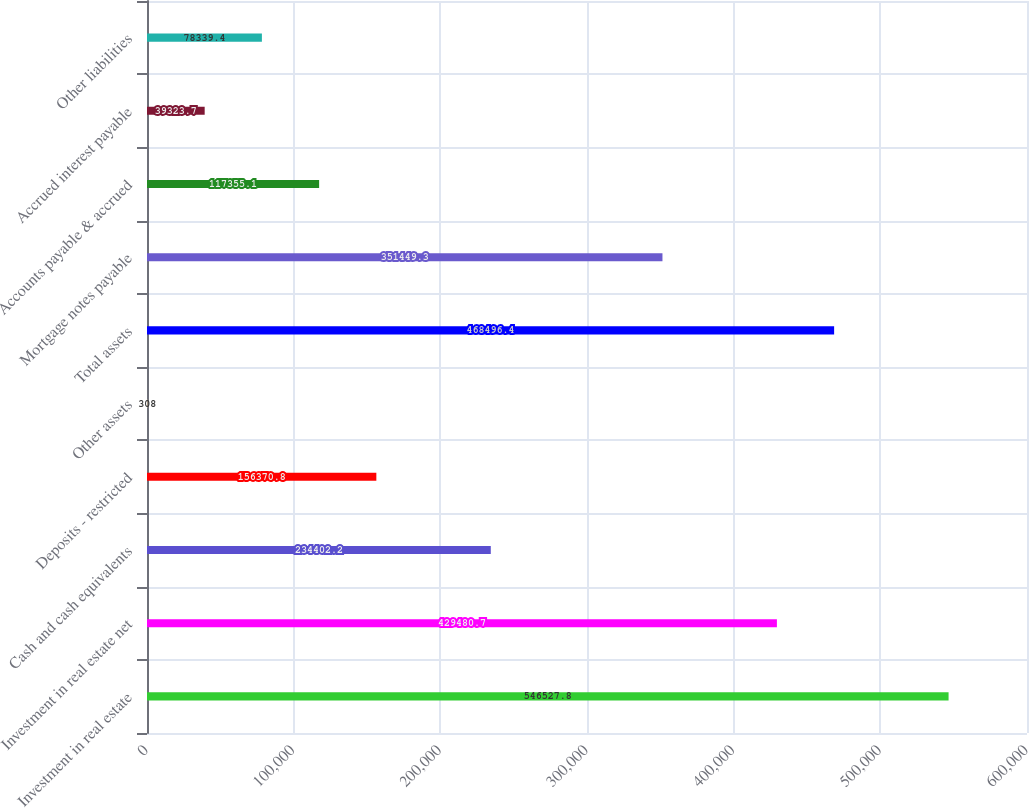Convert chart to OTSL. <chart><loc_0><loc_0><loc_500><loc_500><bar_chart><fcel>Investment in real estate<fcel>Investment in real estate net<fcel>Cash and cash equivalents<fcel>Deposits - restricted<fcel>Other assets<fcel>Total assets<fcel>Mortgage notes payable<fcel>Accounts payable & accrued<fcel>Accrued interest payable<fcel>Other liabilities<nl><fcel>546528<fcel>429481<fcel>234402<fcel>156371<fcel>308<fcel>468496<fcel>351449<fcel>117355<fcel>39323.7<fcel>78339.4<nl></chart> 